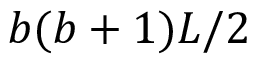Convert formula to latex. <formula><loc_0><loc_0><loc_500><loc_500>b ( b + 1 ) L / 2</formula> 